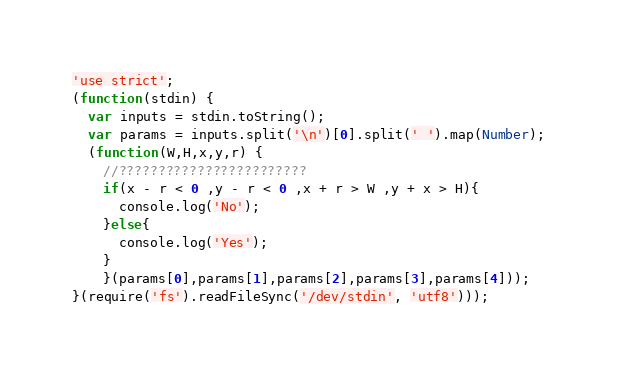Convert code to text. <code><loc_0><loc_0><loc_500><loc_500><_JavaScript_>'use strict';
(function(stdin) { 
  var inputs = stdin.toString();
  var params = inputs.split('\n')[0].split(' ').map(Number);
  (function(W,H,x,y,r) {
    //????????????????????????
    if(x - r < 0 ,y - r < 0 ,x + r > W ,y + x > H){
      console.log('No');
    }else{
      console.log('Yes');
    }
    }(params[0],params[1],params[2],params[3],params[4])); 
}(require('fs').readFileSync('/dev/stdin', 'utf8')));</code> 